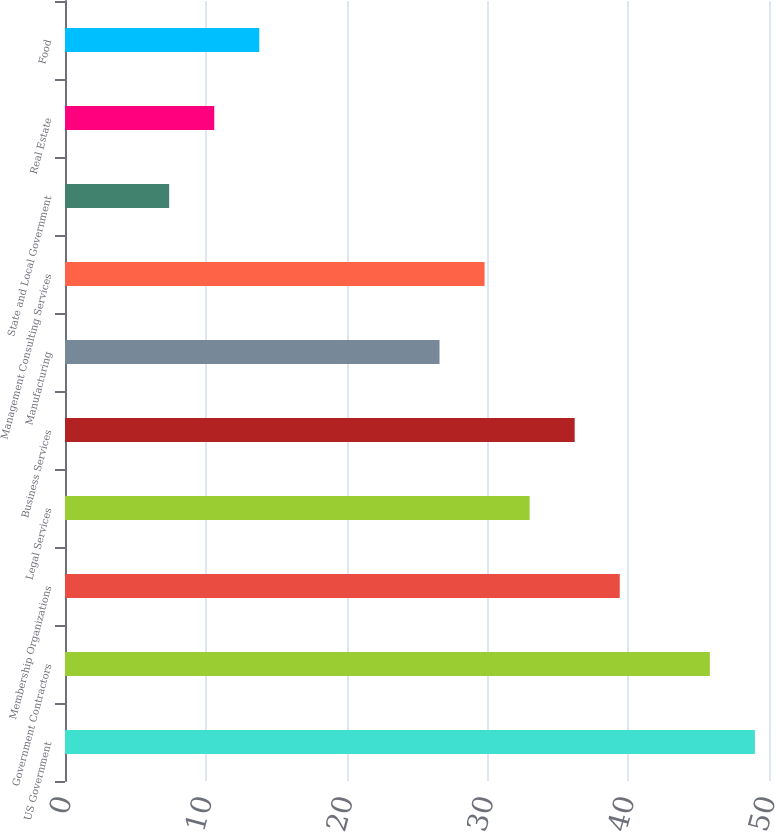Convert chart. <chart><loc_0><loc_0><loc_500><loc_500><bar_chart><fcel>US Government<fcel>Government Contractors<fcel>Membership Organizations<fcel>Legal Services<fcel>Business Services<fcel>Manufacturing<fcel>Management Consulting Services<fcel>State and Local Government<fcel>Real Estate<fcel>Food<nl><fcel>49<fcel>45.8<fcel>39.4<fcel>33<fcel>36.2<fcel>26.6<fcel>29.8<fcel>7.4<fcel>10.6<fcel>13.8<nl></chart> 